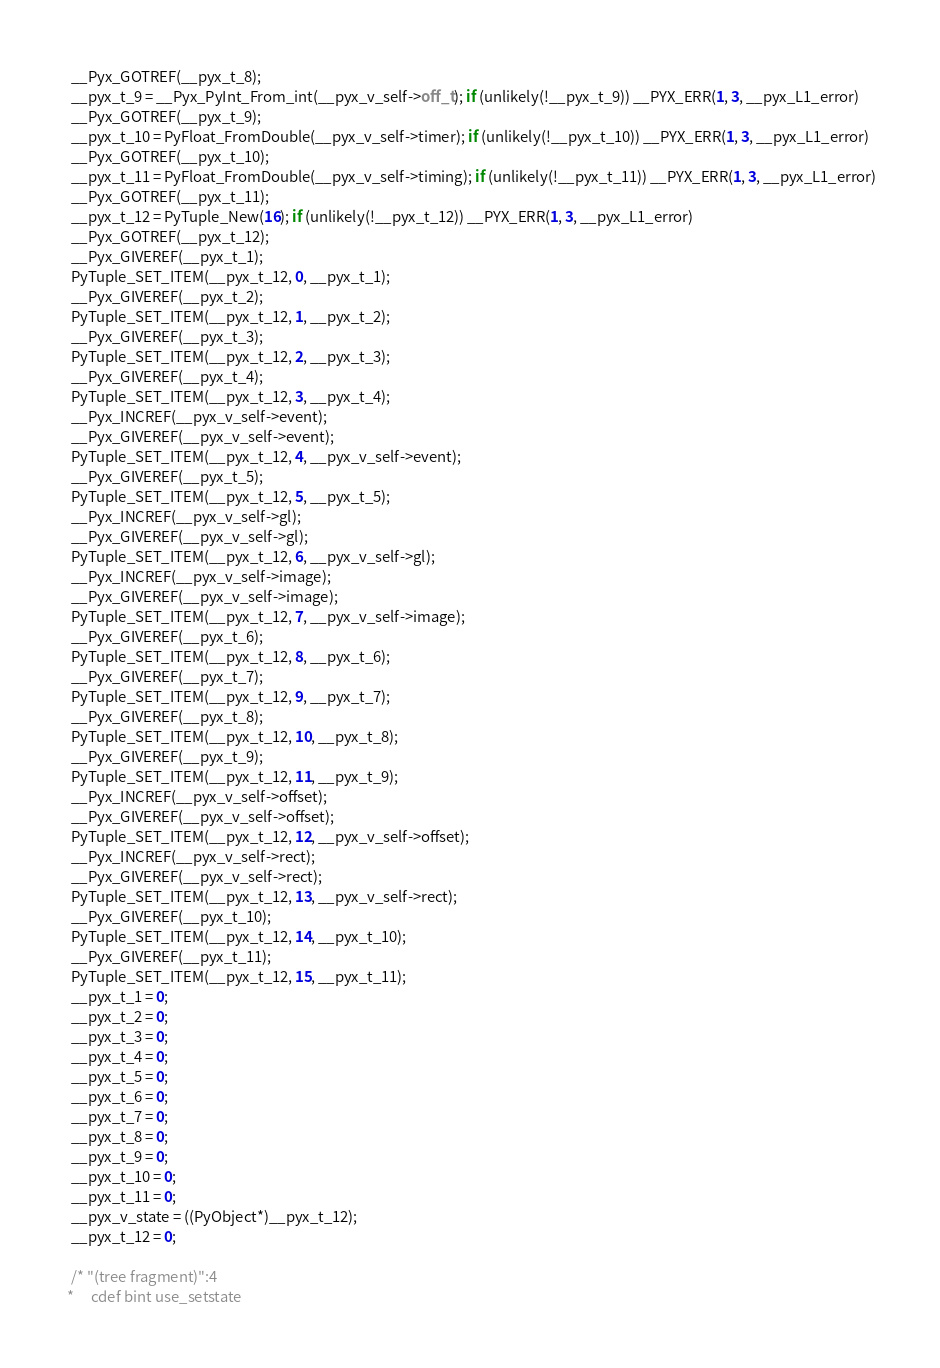Convert code to text. <code><loc_0><loc_0><loc_500><loc_500><_C_>  __Pyx_GOTREF(__pyx_t_8);
  __pyx_t_9 = __Pyx_PyInt_From_int(__pyx_v_self->off_t); if (unlikely(!__pyx_t_9)) __PYX_ERR(1, 3, __pyx_L1_error)
  __Pyx_GOTREF(__pyx_t_9);
  __pyx_t_10 = PyFloat_FromDouble(__pyx_v_self->timer); if (unlikely(!__pyx_t_10)) __PYX_ERR(1, 3, __pyx_L1_error)
  __Pyx_GOTREF(__pyx_t_10);
  __pyx_t_11 = PyFloat_FromDouble(__pyx_v_self->timing); if (unlikely(!__pyx_t_11)) __PYX_ERR(1, 3, __pyx_L1_error)
  __Pyx_GOTREF(__pyx_t_11);
  __pyx_t_12 = PyTuple_New(16); if (unlikely(!__pyx_t_12)) __PYX_ERR(1, 3, __pyx_L1_error)
  __Pyx_GOTREF(__pyx_t_12);
  __Pyx_GIVEREF(__pyx_t_1);
  PyTuple_SET_ITEM(__pyx_t_12, 0, __pyx_t_1);
  __Pyx_GIVEREF(__pyx_t_2);
  PyTuple_SET_ITEM(__pyx_t_12, 1, __pyx_t_2);
  __Pyx_GIVEREF(__pyx_t_3);
  PyTuple_SET_ITEM(__pyx_t_12, 2, __pyx_t_3);
  __Pyx_GIVEREF(__pyx_t_4);
  PyTuple_SET_ITEM(__pyx_t_12, 3, __pyx_t_4);
  __Pyx_INCREF(__pyx_v_self->event);
  __Pyx_GIVEREF(__pyx_v_self->event);
  PyTuple_SET_ITEM(__pyx_t_12, 4, __pyx_v_self->event);
  __Pyx_GIVEREF(__pyx_t_5);
  PyTuple_SET_ITEM(__pyx_t_12, 5, __pyx_t_5);
  __Pyx_INCREF(__pyx_v_self->gl);
  __Pyx_GIVEREF(__pyx_v_self->gl);
  PyTuple_SET_ITEM(__pyx_t_12, 6, __pyx_v_self->gl);
  __Pyx_INCREF(__pyx_v_self->image);
  __Pyx_GIVEREF(__pyx_v_self->image);
  PyTuple_SET_ITEM(__pyx_t_12, 7, __pyx_v_self->image);
  __Pyx_GIVEREF(__pyx_t_6);
  PyTuple_SET_ITEM(__pyx_t_12, 8, __pyx_t_6);
  __Pyx_GIVEREF(__pyx_t_7);
  PyTuple_SET_ITEM(__pyx_t_12, 9, __pyx_t_7);
  __Pyx_GIVEREF(__pyx_t_8);
  PyTuple_SET_ITEM(__pyx_t_12, 10, __pyx_t_8);
  __Pyx_GIVEREF(__pyx_t_9);
  PyTuple_SET_ITEM(__pyx_t_12, 11, __pyx_t_9);
  __Pyx_INCREF(__pyx_v_self->offset);
  __Pyx_GIVEREF(__pyx_v_self->offset);
  PyTuple_SET_ITEM(__pyx_t_12, 12, __pyx_v_self->offset);
  __Pyx_INCREF(__pyx_v_self->rect);
  __Pyx_GIVEREF(__pyx_v_self->rect);
  PyTuple_SET_ITEM(__pyx_t_12, 13, __pyx_v_self->rect);
  __Pyx_GIVEREF(__pyx_t_10);
  PyTuple_SET_ITEM(__pyx_t_12, 14, __pyx_t_10);
  __Pyx_GIVEREF(__pyx_t_11);
  PyTuple_SET_ITEM(__pyx_t_12, 15, __pyx_t_11);
  __pyx_t_1 = 0;
  __pyx_t_2 = 0;
  __pyx_t_3 = 0;
  __pyx_t_4 = 0;
  __pyx_t_5 = 0;
  __pyx_t_6 = 0;
  __pyx_t_7 = 0;
  __pyx_t_8 = 0;
  __pyx_t_9 = 0;
  __pyx_t_10 = 0;
  __pyx_t_11 = 0;
  __pyx_v_state = ((PyObject*)__pyx_t_12);
  __pyx_t_12 = 0;

  /* "(tree fragment)":4
 *     cdef bint use_setstate</code> 